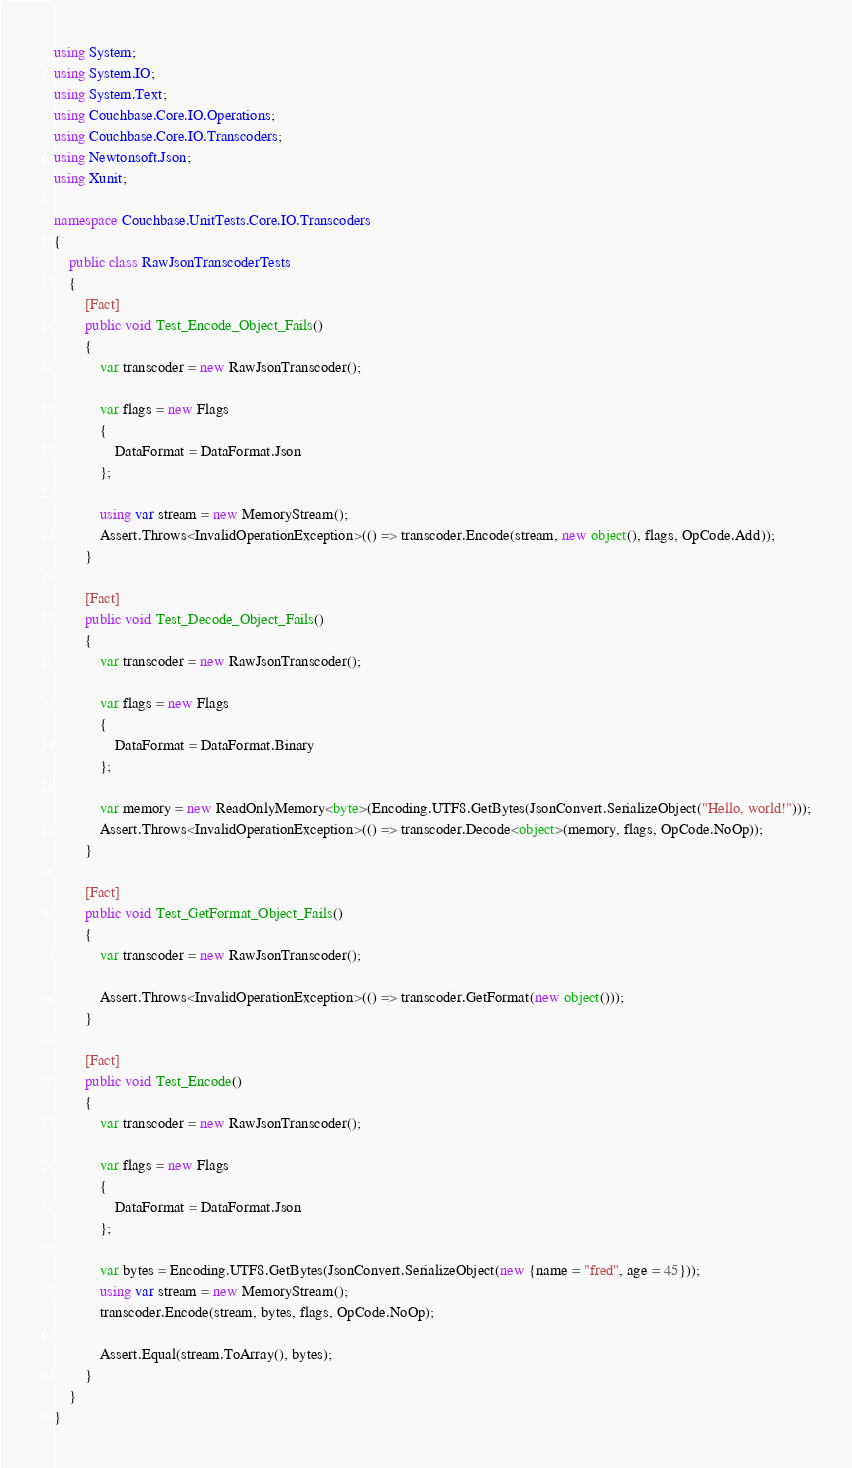<code> <loc_0><loc_0><loc_500><loc_500><_C#_>using System;
using System.IO;
using System.Text;
using Couchbase.Core.IO.Operations;
using Couchbase.Core.IO.Transcoders;
using Newtonsoft.Json;
using Xunit;

namespace Couchbase.UnitTests.Core.IO.Transcoders
{
    public class RawJsonTranscoderTests
    {
        [Fact]
        public void Test_Encode_Object_Fails()
        {
            var transcoder = new RawJsonTranscoder();

            var flags = new Flags
            {
                DataFormat = DataFormat.Json
            };

            using var stream = new MemoryStream();
            Assert.Throws<InvalidOperationException>(() => transcoder.Encode(stream, new object(), flags, OpCode.Add));
        }

        [Fact]
        public void Test_Decode_Object_Fails()
        {
            var transcoder = new RawJsonTranscoder();

            var flags = new Flags
            {
                DataFormat = DataFormat.Binary
            };

            var memory = new ReadOnlyMemory<byte>(Encoding.UTF8.GetBytes(JsonConvert.SerializeObject("Hello, world!")));
            Assert.Throws<InvalidOperationException>(() => transcoder.Decode<object>(memory, flags, OpCode.NoOp));
        }

        [Fact]
        public void Test_GetFormat_Object_Fails()
        {
            var transcoder = new RawJsonTranscoder();

            Assert.Throws<InvalidOperationException>(() => transcoder.GetFormat(new object()));
        }

        [Fact]
        public void Test_Encode()
        {
            var transcoder = new RawJsonTranscoder();

            var flags = new Flags
            {
                DataFormat = DataFormat.Json
            };

            var bytes = Encoding.UTF8.GetBytes(JsonConvert.SerializeObject(new {name = "fred", age = 45}));
            using var stream = new MemoryStream();
            transcoder.Encode(stream, bytes, flags, OpCode.NoOp);

            Assert.Equal(stream.ToArray(), bytes);
        }
    }
}
</code> 